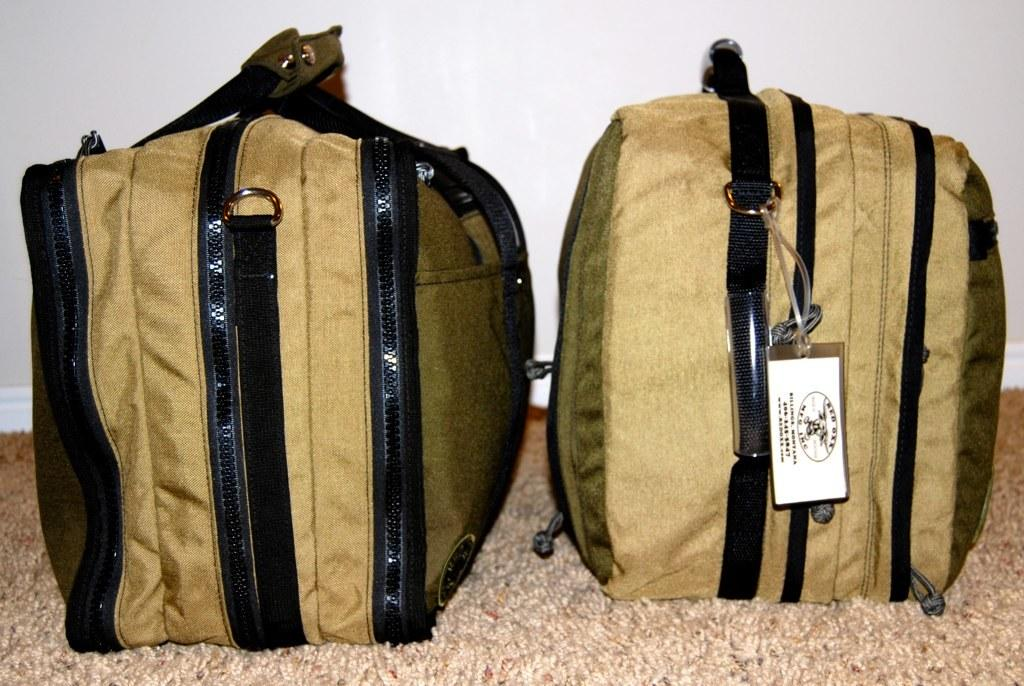What can be seen in the image related to travel? There is baggage in the image. Can you describe any specific details about the baggage? There is a tag on the bag. What direction is the division taking place in the image? There is no division present in the image. 